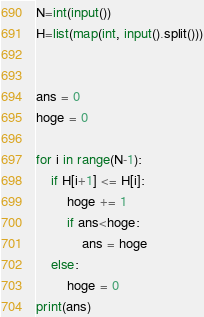<code> <loc_0><loc_0><loc_500><loc_500><_Python_>N=int(input())
H=list(map(int, input().split()))


ans = 0
hoge = 0

for i in range(N-1):
    if H[i+1] <= H[i]:
        hoge += 1
        if ans<hoge:
            ans = hoge
    else:
        hoge = 0
print(ans)</code> 